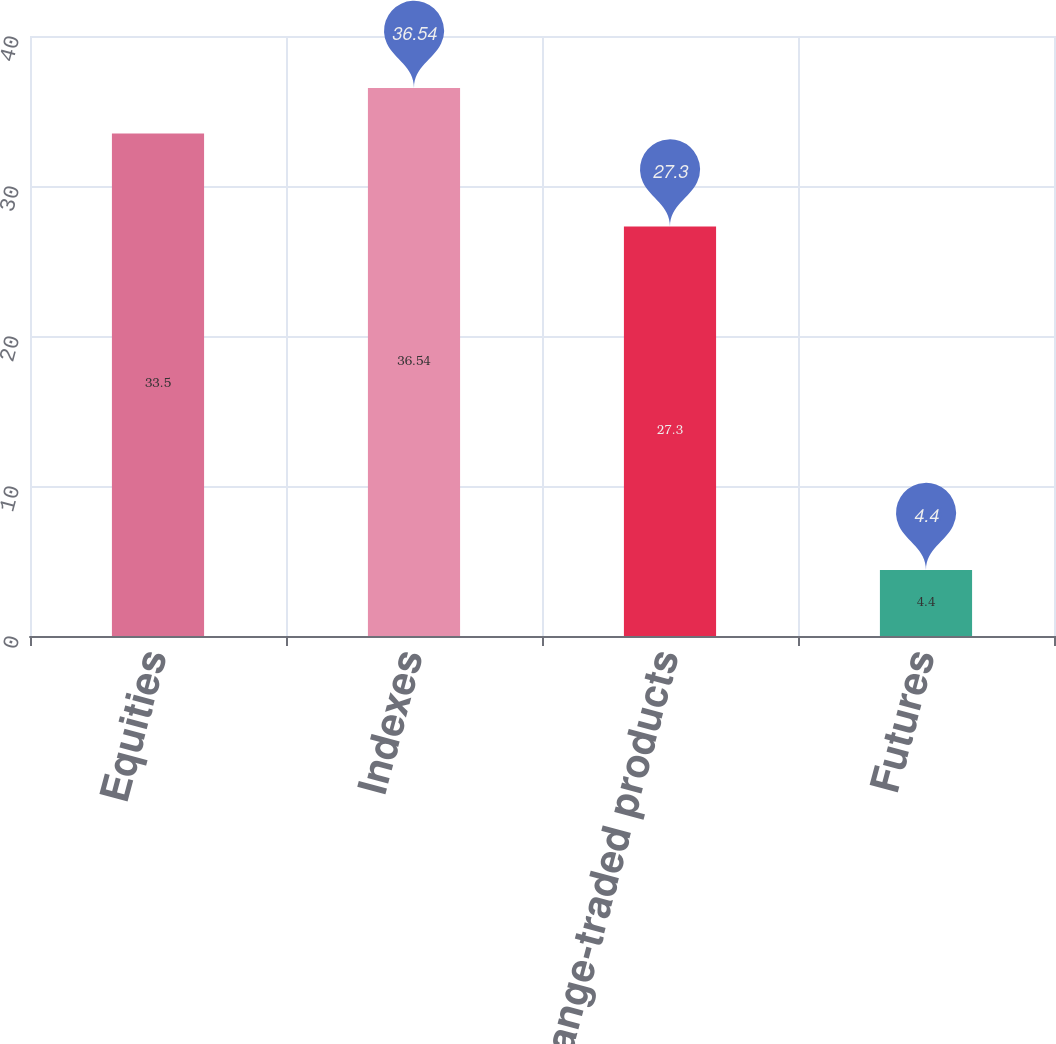Convert chart. <chart><loc_0><loc_0><loc_500><loc_500><bar_chart><fcel>Equities<fcel>Indexes<fcel>Exchange-traded products<fcel>Futures<nl><fcel>33.5<fcel>36.54<fcel>27.3<fcel>4.4<nl></chart> 